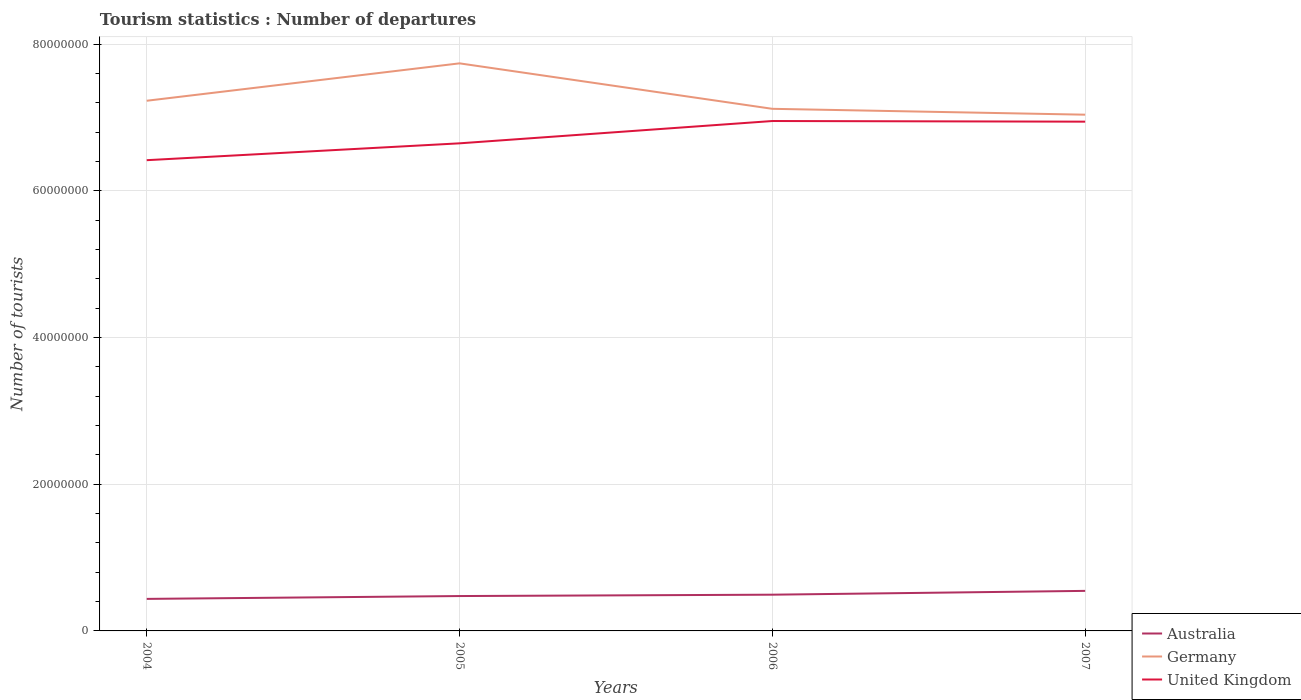Is the number of lines equal to the number of legend labels?
Give a very brief answer. Yes. Across all years, what is the maximum number of tourist departures in Australia?
Keep it short and to the point. 4.37e+06. What is the total number of tourist departures in Germany in the graph?
Make the answer very short. 1.10e+06. What is the difference between the highest and the second highest number of tourist departures in United Kingdom?
Offer a very short reply. 5.34e+06. How many years are there in the graph?
Make the answer very short. 4. What is the difference between two consecutive major ticks on the Y-axis?
Your response must be concise. 2.00e+07. Are the values on the major ticks of Y-axis written in scientific E-notation?
Your answer should be compact. No. Where does the legend appear in the graph?
Your answer should be very brief. Bottom right. What is the title of the graph?
Give a very brief answer. Tourism statistics : Number of departures. Does "Belgium" appear as one of the legend labels in the graph?
Your answer should be very brief. No. What is the label or title of the X-axis?
Your answer should be compact. Years. What is the label or title of the Y-axis?
Give a very brief answer. Number of tourists. What is the Number of tourists of Australia in 2004?
Offer a terse response. 4.37e+06. What is the Number of tourists of Germany in 2004?
Your answer should be very brief. 7.23e+07. What is the Number of tourists of United Kingdom in 2004?
Make the answer very short. 6.42e+07. What is the Number of tourists in Australia in 2005?
Your answer should be very brief. 4.76e+06. What is the Number of tourists in Germany in 2005?
Make the answer very short. 7.74e+07. What is the Number of tourists of United Kingdom in 2005?
Keep it short and to the point. 6.65e+07. What is the Number of tourists in Australia in 2006?
Provide a short and direct response. 4.94e+06. What is the Number of tourists in Germany in 2006?
Keep it short and to the point. 7.12e+07. What is the Number of tourists of United Kingdom in 2006?
Ensure brevity in your answer.  6.95e+07. What is the Number of tourists in Australia in 2007?
Your answer should be very brief. 5.46e+06. What is the Number of tourists in Germany in 2007?
Offer a terse response. 7.04e+07. What is the Number of tourists of United Kingdom in 2007?
Keep it short and to the point. 6.94e+07. Across all years, what is the maximum Number of tourists in Australia?
Your answer should be compact. 5.46e+06. Across all years, what is the maximum Number of tourists in Germany?
Your response must be concise. 7.74e+07. Across all years, what is the maximum Number of tourists in United Kingdom?
Keep it short and to the point. 6.95e+07. Across all years, what is the minimum Number of tourists in Australia?
Keep it short and to the point. 4.37e+06. Across all years, what is the minimum Number of tourists in Germany?
Offer a very short reply. 7.04e+07. Across all years, what is the minimum Number of tourists of United Kingdom?
Make the answer very short. 6.42e+07. What is the total Number of tourists of Australia in the graph?
Your response must be concise. 1.95e+07. What is the total Number of tourists of Germany in the graph?
Your answer should be very brief. 2.91e+08. What is the total Number of tourists in United Kingdom in the graph?
Make the answer very short. 2.70e+08. What is the difference between the Number of tourists of Australia in 2004 and that in 2005?
Give a very brief answer. -3.87e+05. What is the difference between the Number of tourists of Germany in 2004 and that in 2005?
Provide a succinct answer. -5.10e+06. What is the difference between the Number of tourists of United Kingdom in 2004 and that in 2005?
Keep it short and to the point. -2.30e+06. What is the difference between the Number of tourists in Australia in 2004 and that in 2006?
Your answer should be compact. -5.72e+05. What is the difference between the Number of tourists of Germany in 2004 and that in 2006?
Keep it short and to the point. 1.10e+06. What is the difference between the Number of tourists of United Kingdom in 2004 and that in 2006?
Provide a short and direct response. -5.34e+06. What is the difference between the Number of tourists of Australia in 2004 and that in 2007?
Provide a succinct answer. -1.09e+06. What is the difference between the Number of tourists of Germany in 2004 and that in 2007?
Make the answer very short. 1.90e+06. What is the difference between the Number of tourists in United Kingdom in 2004 and that in 2007?
Ensure brevity in your answer.  -5.26e+06. What is the difference between the Number of tourists of Australia in 2005 and that in 2006?
Provide a short and direct response. -1.85e+05. What is the difference between the Number of tourists of Germany in 2005 and that in 2006?
Your answer should be very brief. 6.20e+06. What is the difference between the Number of tourists in United Kingdom in 2005 and that in 2006?
Offer a very short reply. -3.04e+06. What is the difference between the Number of tourists in Australia in 2005 and that in 2007?
Keep it short and to the point. -7.06e+05. What is the difference between the Number of tourists in United Kingdom in 2005 and that in 2007?
Keep it short and to the point. -2.96e+06. What is the difference between the Number of tourists in Australia in 2006 and that in 2007?
Provide a succinct answer. -5.21e+05. What is the difference between the Number of tourists of United Kingdom in 2006 and that in 2007?
Your answer should be very brief. 8.60e+04. What is the difference between the Number of tourists in Australia in 2004 and the Number of tourists in Germany in 2005?
Make the answer very short. -7.30e+07. What is the difference between the Number of tourists of Australia in 2004 and the Number of tourists of United Kingdom in 2005?
Your answer should be compact. -6.21e+07. What is the difference between the Number of tourists of Germany in 2004 and the Number of tourists of United Kingdom in 2005?
Offer a very short reply. 5.81e+06. What is the difference between the Number of tourists in Australia in 2004 and the Number of tourists in Germany in 2006?
Ensure brevity in your answer.  -6.68e+07. What is the difference between the Number of tourists in Australia in 2004 and the Number of tourists in United Kingdom in 2006?
Your answer should be very brief. -6.52e+07. What is the difference between the Number of tourists in Germany in 2004 and the Number of tourists in United Kingdom in 2006?
Provide a succinct answer. 2.76e+06. What is the difference between the Number of tourists in Australia in 2004 and the Number of tourists in Germany in 2007?
Your answer should be compact. -6.60e+07. What is the difference between the Number of tourists in Australia in 2004 and the Number of tourists in United Kingdom in 2007?
Ensure brevity in your answer.  -6.51e+07. What is the difference between the Number of tourists in Germany in 2004 and the Number of tourists in United Kingdom in 2007?
Offer a terse response. 2.85e+06. What is the difference between the Number of tourists in Australia in 2005 and the Number of tourists in Germany in 2006?
Your answer should be very brief. -6.64e+07. What is the difference between the Number of tourists in Australia in 2005 and the Number of tourists in United Kingdom in 2006?
Your answer should be very brief. -6.48e+07. What is the difference between the Number of tourists in Germany in 2005 and the Number of tourists in United Kingdom in 2006?
Make the answer very short. 7.86e+06. What is the difference between the Number of tourists of Australia in 2005 and the Number of tourists of Germany in 2007?
Give a very brief answer. -6.56e+07. What is the difference between the Number of tourists of Australia in 2005 and the Number of tourists of United Kingdom in 2007?
Make the answer very short. -6.47e+07. What is the difference between the Number of tourists in Germany in 2005 and the Number of tourists in United Kingdom in 2007?
Offer a very short reply. 7.95e+06. What is the difference between the Number of tourists of Australia in 2006 and the Number of tourists of Germany in 2007?
Ensure brevity in your answer.  -6.55e+07. What is the difference between the Number of tourists of Australia in 2006 and the Number of tourists of United Kingdom in 2007?
Offer a terse response. -6.45e+07. What is the difference between the Number of tourists of Germany in 2006 and the Number of tourists of United Kingdom in 2007?
Offer a very short reply. 1.75e+06. What is the average Number of tourists of Australia per year?
Provide a short and direct response. 4.88e+06. What is the average Number of tourists in Germany per year?
Ensure brevity in your answer.  7.28e+07. What is the average Number of tourists of United Kingdom per year?
Keep it short and to the point. 6.74e+07. In the year 2004, what is the difference between the Number of tourists in Australia and Number of tourists in Germany?
Offer a very short reply. -6.79e+07. In the year 2004, what is the difference between the Number of tourists in Australia and Number of tourists in United Kingdom?
Offer a terse response. -5.98e+07. In the year 2004, what is the difference between the Number of tourists in Germany and Number of tourists in United Kingdom?
Your answer should be very brief. 8.11e+06. In the year 2005, what is the difference between the Number of tourists in Australia and Number of tourists in Germany?
Keep it short and to the point. -7.26e+07. In the year 2005, what is the difference between the Number of tourists in Australia and Number of tourists in United Kingdom?
Ensure brevity in your answer.  -6.17e+07. In the year 2005, what is the difference between the Number of tourists of Germany and Number of tourists of United Kingdom?
Give a very brief answer. 1.09e+07. In the year 2006, what is the difference between the Number of tourists of Australia and Number of tourists of Germany?
Make the answer very short. -6.63e+07. In the year 2006, what is the difference between the Number of tourists of Australia and Number of tourists of United Kingdom?
Offer a terse response. -6.46e+07. In the year 2006, what is the difference between the Number of tourists of Germany and Number of tourists of United Kingdom?
Offer a very short reply. 1.66e+06. In the year 2007, what is the difference between the Number of tourists of Australia and Number of tourists of Germany?
Make the answer very short. -6.49e+07. In the year 2007, what is the difference between the Number of tourists of Australia and Number of tourists of United Kingdom?
Provide a succinct answer. -6.40e+07. In the year 2007, what is the difference between the Number of tourists in Germany and Number of tourists in United Kingdom?
Your response must be concise. 9.50e+05. What is the ratio of the Number of tourists in Australia in 2004 to that in 2005?
Your answer should be very brief. 0.92. What is the ratio of the Number of tourists in Germany in 2004 to that in 2005?
Keep it short and to the point. 0.93. What is the ratio of the Number of tourists in United Kingdom in 2004 to that in 2005?
Your answer should be very brief. 0.97. What is the ratio of the Number of tourists in Australia in 2004 to that in 2006?
Give a very brief answer. 0.88. What is the ratio of the Number of tourists of Germany in 2004 to that in 2006?
Provide a succinct answer. 1.02. What is the ratio of the Number of tourists in United Kingdom in 2004 to that in 2006?
Make the answer very short. 0.92. What is the ratio of the Number of tourists of Australia in 2004 to that in 2007?
Keep it short and to the point. 0.8. What is the ratio of the Number of tourists in United Kingdom in 2004 to that in 2007?
Offer a very short reply. 0.92. What is the ratio of the Number of tourists of Australia in 2005 to that in 2006?
Provide a short and direct response. 0.96. What is the ratio of the Number of tourists of Germany in 2005 to that in 2006?
Make the answer very short. 1.09. What is the ratio of the Number of tourists of United Kingdom in 2005 to that in 2006?
Provide a short and direct response. 0.96. What is the ratio of the Number of tourists of Australia in 2005 to that in 2007?
Your answer should be compact. 0.87. What is the ratio of the Number of tourists of Germany in 2005 to that in 2007?
Make the answer very short. 1.1. What is the ratio of the Number of tourists of United Kingdom in 2005 to that in 2007?
Your answer should be very brief. 0.96. What is the ratio of the Number of tourists in Australia in 2006 to that in 2007?
Offer a terse response. 0.9. What is the ratio of the Number of tourists of Germany in 2006 to that in 2007?
Your answer should be compact. 1.01. What is the ratio of the Number of tourists of United Kingdom in 2006 to that in 2007?
Your answer should be very brief. 1. What is the difference between the highest and the second highest Number of tourists of Australia?
Ensure brevity in your answer.  5.21e+05. What is the difference between the highest and the second highest Number of tourists of Germany?
Ensure brevity in your answer.  5.10e+06. What is the difference between the highest and the second highest Number of tourists of United Kingdom?
Your answer should be very brief. 8.60e+04. What is the difference between the highest and the lowest Number of tourists of Australia?
Provide a short and direct response. 1.09e+06. What is the difference between the highest and the lowest Number of tourists in United Kingdom?
Ensure brevity in your answer.  5.34e+06. 